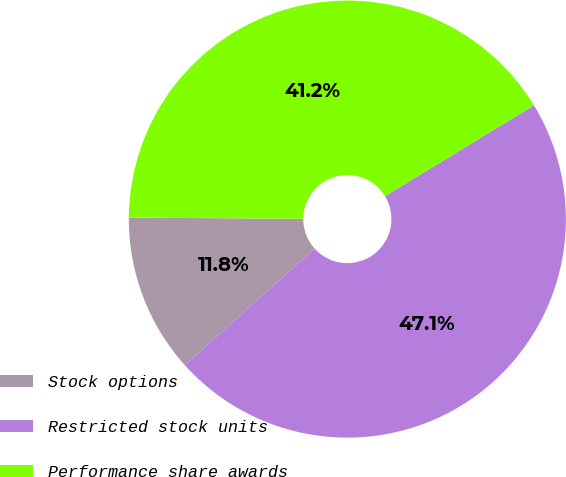<chart> <loc_0><loc_0><loc_500><loc_500><pie_chart><fcel>Stock options<fcel>Restricted stock units<fcel>Performance share awards<nl><fcel>11.76%<fcel>47.06%<fcel>41.18%<nl></chart> 